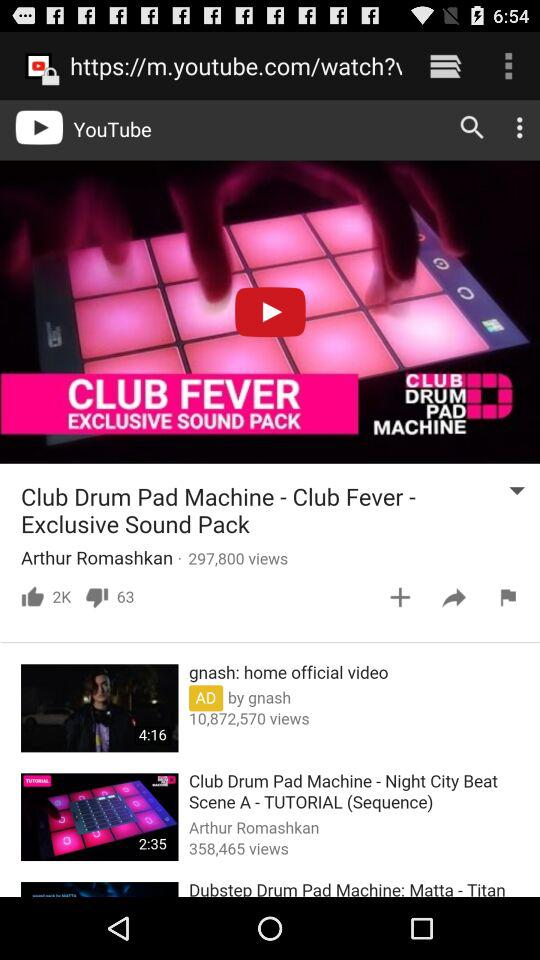How many dislikes are there for "Club Drum Pad Machine - Club Fever"? There are 63 dislikes. 